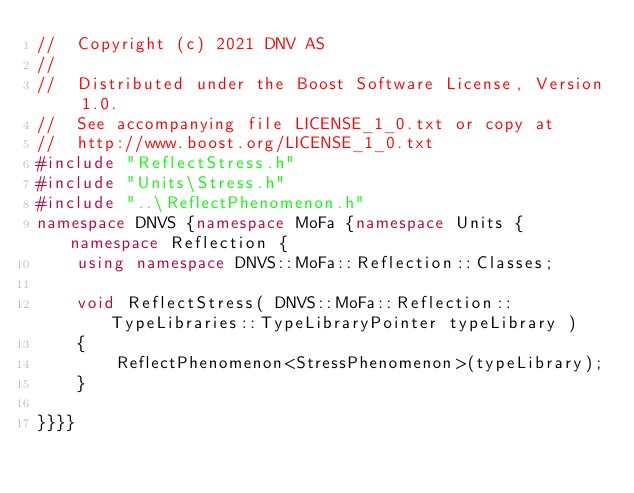Convert code to text. <code><loc_0><loc_0><loc_500><loc_500><_C++_>//  Copyright (c) 2021 DNV AS
//
//  Distributed under the Boost Software License, Version 1.0.
//  See accompanying file LICENSE_1_0.txt or copy at
//  http://www.boost.org/LICENSE_1_0.txt
#include "ReflectStress.h"
#include "Units\Stress.h"
#include "..\ReflectPhenomenon.h"
namespace DNVS {namespace MoFa {namespace Units { namespace Reflection {
    using namespace DNVS::MoFa::Reflection::Classes;

    void ReflectStress( DNVS::MoFa::Reflection::TypeLibraries::TypeLibraryPointer typeLibrary )
    {
        ReflectPhenomenon<StressPhenomenon>(typeLibrary);
    }

}}}}</code> 